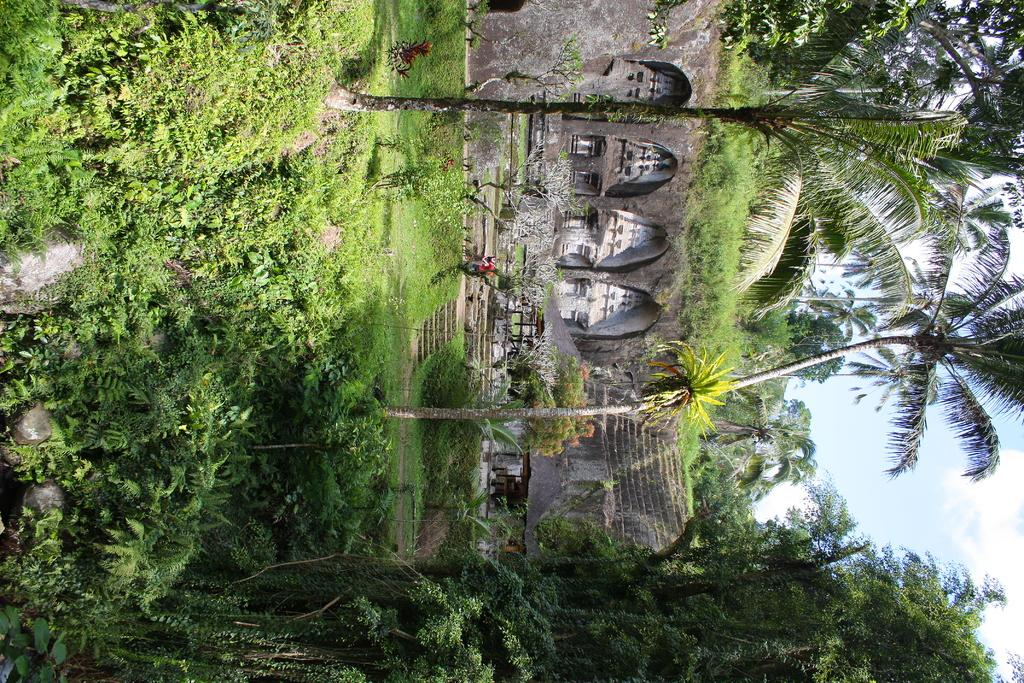What type of vegetation can be seen in the image? There are plants and trees in the image. What is on the ground in the image? There is grass on the ground in the image. What is located in the middle of the image? There is a wall in the middle of the image. What can be seen in the background of the image? Trees and the sky are visible in the background of the image. What type of destruction can be seen in the image? There is no destruction present in the image; it features plants, grass, a wall, trees, and the sky. What is the head of the person doing in the image? There is no person or head present in the image. 